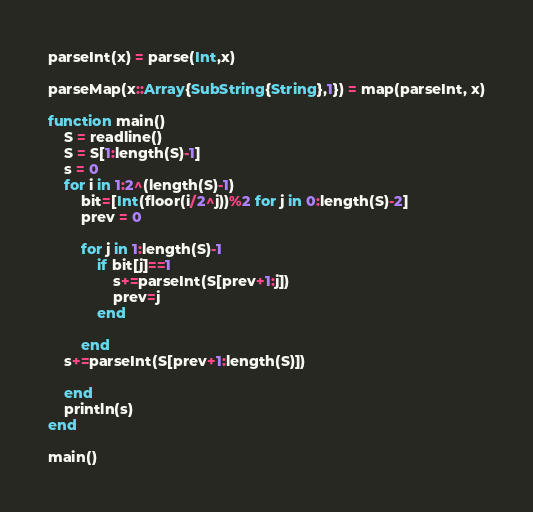<code> <loc_0><loc_0><loc_500><loc_500><_Julia_>parseInt(x) = parse(Int,x)

parseMap(x::Array{SubString{String},1}) = map(parseInt, x)

function main()
    S = readline()
    S = S[1:length(S)-1]
    s = 0
    for i in 1:2^(length(S)-1)
        bit=[Int(floor(i/2^j))%2 for j in 0:length(S)-2]
        prev = 0
        
        for j in 1:length(S)-1
            if bit[j]==1
                s+=parseInt(S[prev+1:j])
                prev=j
            end
            
        end
    s+=parseInt(S[prev+1:length(S)])

    end
    println(s)
end

main()
</code> 